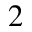Convert formula to latex. <formula><loc_0><loc_0><loc_500><loc_500>_ { 2 }</formula> 